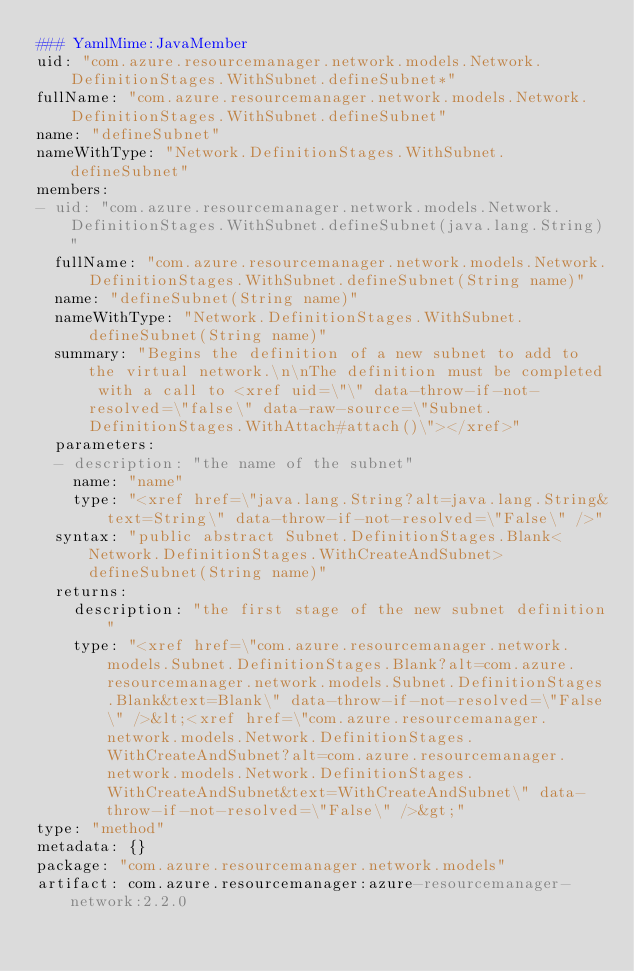Convert code to text. <code><loc_0><loc_0><loc_500><loc_500><_YAML_>### YamlMime:JavaMember
uid: "com.azure.resourcemanager.network.models.Network.DefinitionStages.WithSubnet.defineSubnet*"
fullName: "com.azure.resourcemanager.network.models.Network.DefinitionStages.WithSubnet.defineSubnet"
name: "defineSubnet"
nameWithType: "Network.DefinitionStages.WithSubnet.defineSubnet"
members:
- uid: "com.azure.resourcemanager.network.models.Network.DefinitionStages.WithSubnet.defineSubnet(java.lang.String)"
  fullName: "com.azure.resourcemanager.network.models.Network.DefinitionStages.WithSubnet.defineSubnet(String name)"
  name: "defineSubnet(String name)"
  nameWithType: "Network.DefinitionStages.WithSubnet.defineSubnet(String name)"
  summary: "Begins the definition of a new subnet to add to the virtual network.\n\nThe definition must be completed with a call to <xref uid=\"\" data-throw-if-not-resolved=\"false\" data-raw-source=\"Subnet.DefinitionStages.WithAttach#attach()\"></xref>"
  parameters:
  - description: "the name of the subnet"
    name: "name"
    type: "<xref href=\"java.lang.String?alt=java.lang.String&text=String\" data-throw-if-not-resolved=\"False\" />"
  syntax: "public abstract Subnet.DefinitionStages.Blank<Network.DefinitionStages.WithCreateAndSubnet> defineSubnet(String name)"
  returns:
    description: "the first stage of the new subnet definition"
    type: "<xref href=\"com.azure.resourcemanager.network.models.Subnet.DefinitionStages.Blank?alt=com.azure.resourcemanager.network.models.Subnet.DefinitionStages.Blank&text=Blank\" data-throw-if-not-resolved=\"False\" />&lt;<xref href=\"com.azure.resourcemanager.network.models.Network.DefinitionStages.WithCreateAndSubnet?alt=com.azure.resourcemanager.network.models.Network.DefinitionStages.WithCreateAndSubnet&text=WithCreateAndSubnet\" data-throw-if-not-resolved=\"False\" />&gt;"
type: "method"
metadata: {}
package: "com.azure.resourcemanager.network.models"
artifact: com.azure.resourcemanager:azure-resourcemanager-network:2.2.0
</code> 